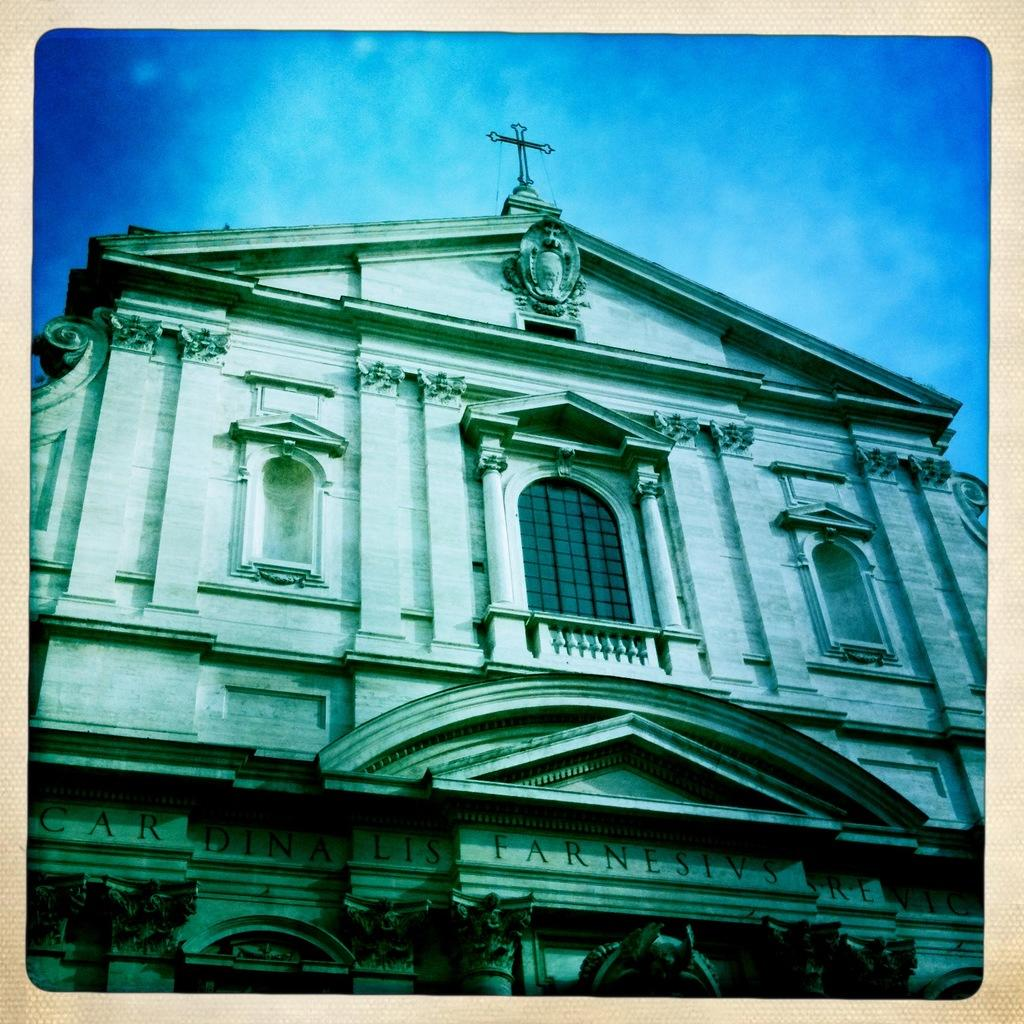What is the main subject in the center of the image? There is a building in the center of the image. What can be seen in the background of the image? Sky is visible in the background of the image. What is present in the sky? There are clouds in the sky. What type of juice is being served at the club in the image? There is no club or juice present in the image; it only features a building and clouds in the sky. 